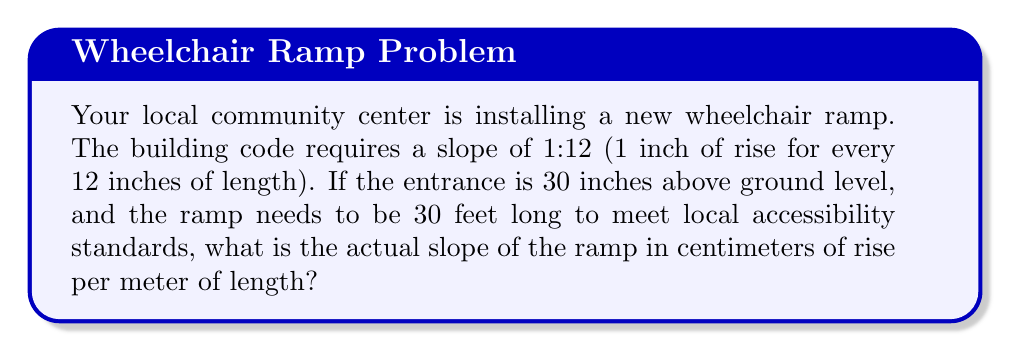Teach me how to tackle this problem. To solve this problem, we need to convert the given measurements to metric units and then calculate the slope. Let's break it down step by step:

1. Convert the height from inches to centimeters:
   $30 \text{ inches} \times 2.54 \text{ cm/inch} = 76.2 \text{ cm}$

2. Convert the length from feet to meters:
   $30 \text{ feet} \times 0.3048 \text{ m/foot} = 9.144 \text{ m}$

3. Calculate the slope:
   Slope = Rise / Run
   $\text{Slope} = \frac{76.2 \text{ cm}}{9.144 \text{ m}}$

4. To express the slope in cm/m, we need to convert the denominator to 100 cm:
   $$\frac{76.2 \text{ cm}}{9.144 \text{ m}} = \frac{76.2 \text{ cm}}{914.4 \text{ cm}} = \frac{76.2}{914.4}$$

5. Multiply both numerator and denominator by $\frac{100}{100}$ to get the rise per 100 cm (1 m):
   $$\frac{76.2}{914.4} \times \frac{100}{100} = \frac{7620}{91440} = \frac{381}{4572} \approx 0.0833$$

6. Convert to centimeters per meter:
   $0.0833 \times 100 \text{ cm/m} = 8.33 \text{ cm/m}$

Therefore, the actual slope of the ramp is approximately 8.33 cm of rise per meter of length.
Answer: $8.33 \text{ cm/m}$ 